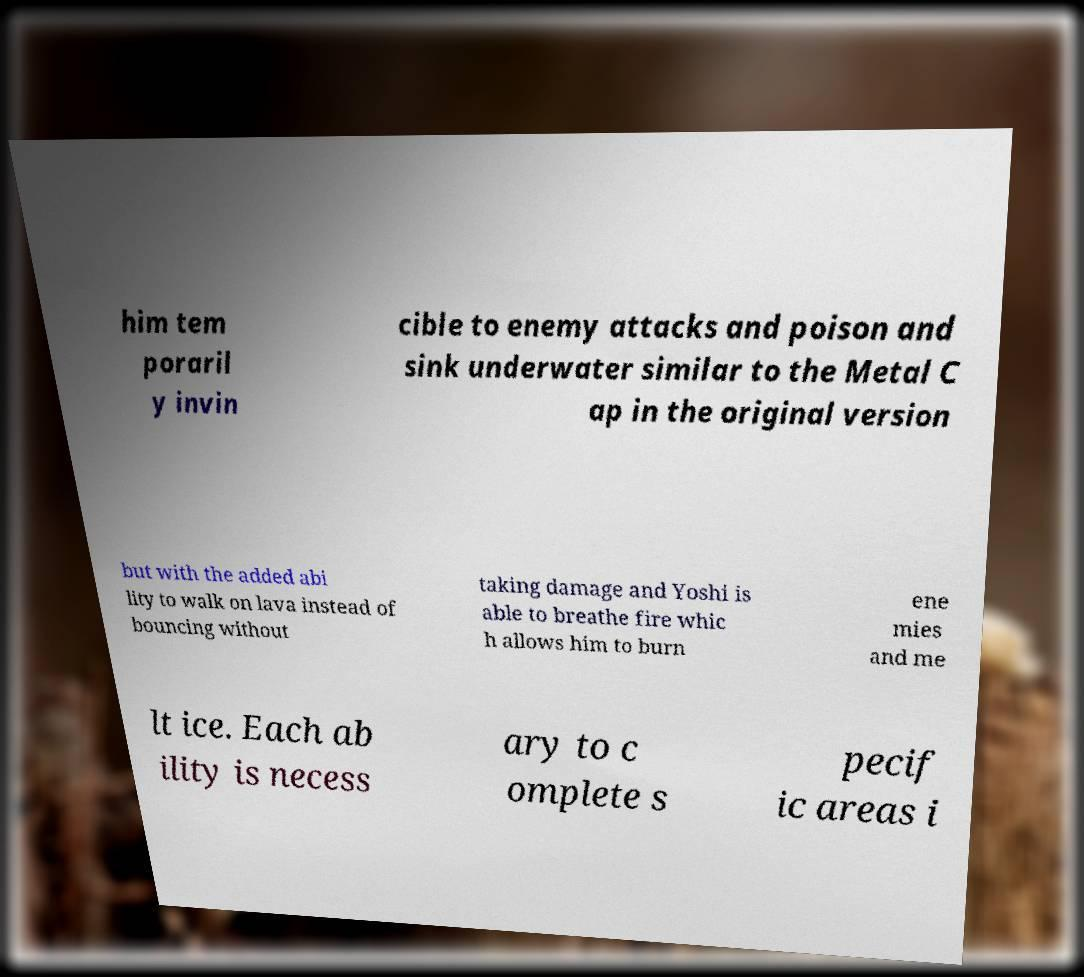Please identify and transcribe the text found in this image. him tem poraril y invin cible to enemy attacks and poison and sink underwater similar to the Metal C ap in the original version but with the added abi lity to walk on lava instead of bouncing without taking damage and Yoshi is able to breathe fire whic h allows him to burn ene mies and me lt ice. Each ab ility is necess ary to c omplete s pecif ic areas i 